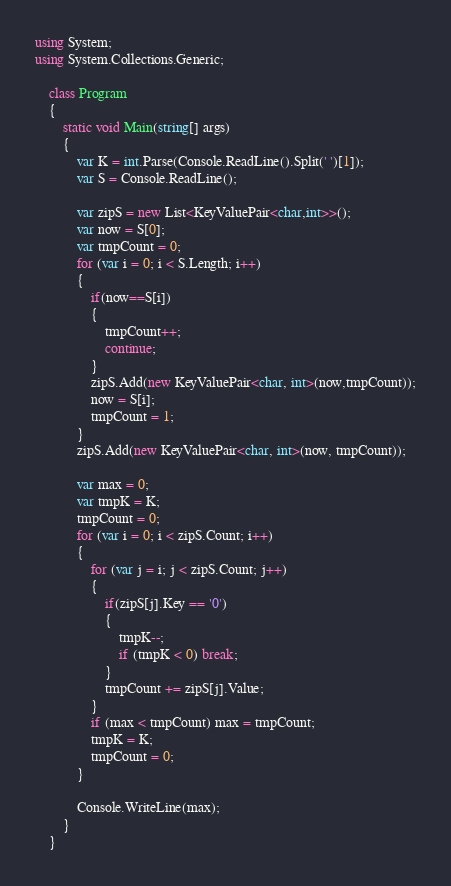Convert code to text. <code><loc_0><loc_0><loc_500><loc_500><_C#_>using System;
using System.Collections.Generic;

    class Program
    {
        static void Main(string[] args)
        {
            var K = int.Parse(Console.ReadLine().Split(' ')[1]);
            var S = Console.ReadLine();

            var zipS = new List<KeyValuePair<char,int>>();
            var now = S[0];
            var tmpCount = 0;
            for (var i = 0; i < S.Length; i++)
            {
                if(now==S[i])
                {
                    tmpCount++;
                    continue;
                }
                zipS.Add(new KeyValuePair<char, int>(now,tmpCount));
                now = S[i];
                tmpCount = 1;
            }
            zipS.Add(new KeyValuePair<char, int>(now, tmpCount));

            var max = 0;
            var tmpK = K;
            tmpCount = 0;
            for (var i = 0; i < zipS.Count; i++)
            {
                for (var j = i; j < zipS.Count; j++)
                {
                    if(zipS[j].Key == '0')
                    {
                        tmpK--;
                        if (tmpK < 0) break;
                    }
                    tmpCount += zipS[j].Value;
                }
                if (max < tmpCount) max = tmpCount;
                tmpK = K;
                tmpCount = 0;
            }

            Console.WriteLine(max);
        }
    }</code> 